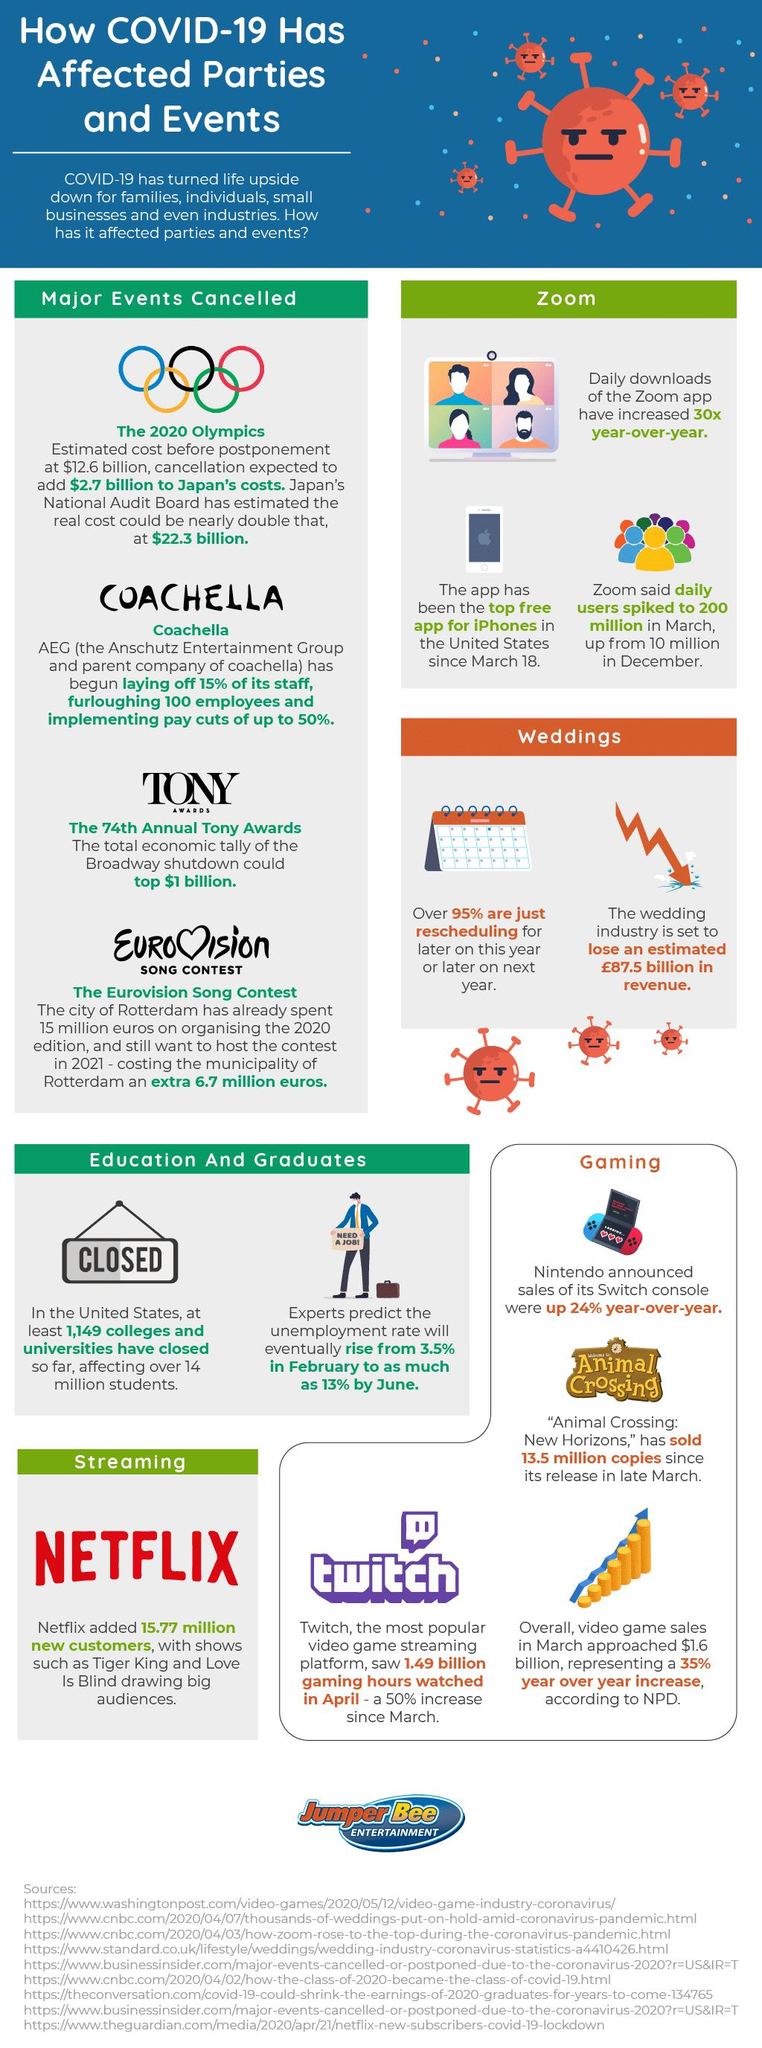Draw attention to some important aspects in this diagram. The number of sources listed is 9. 